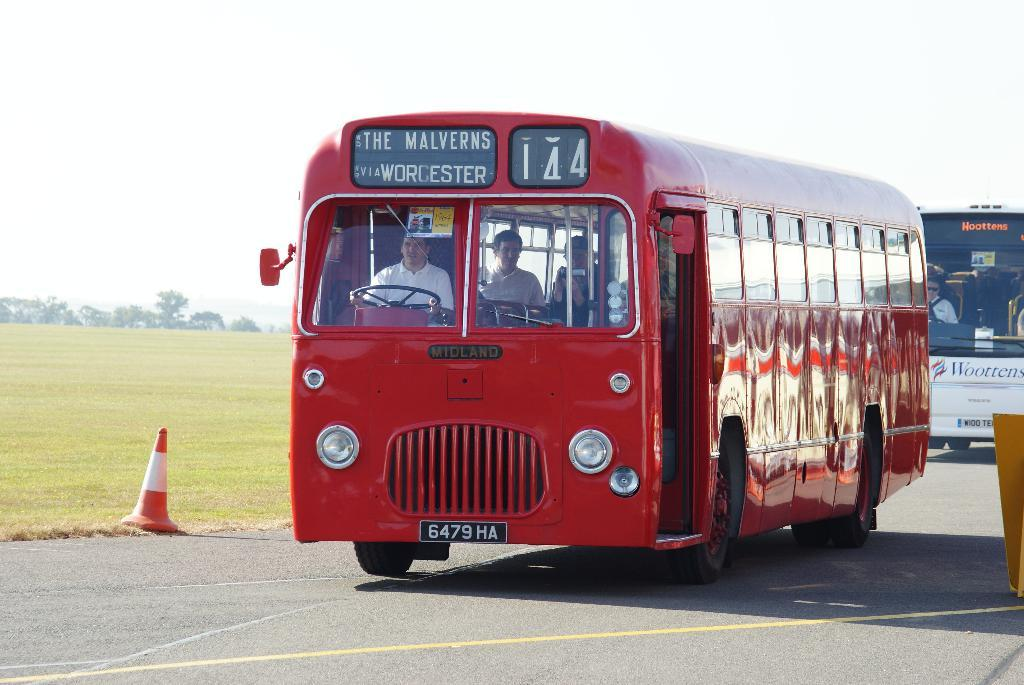Provide a one-sentence caption for the provided image. A bright red bus with a sign that reads, The Malverns via Worcester and 144. 